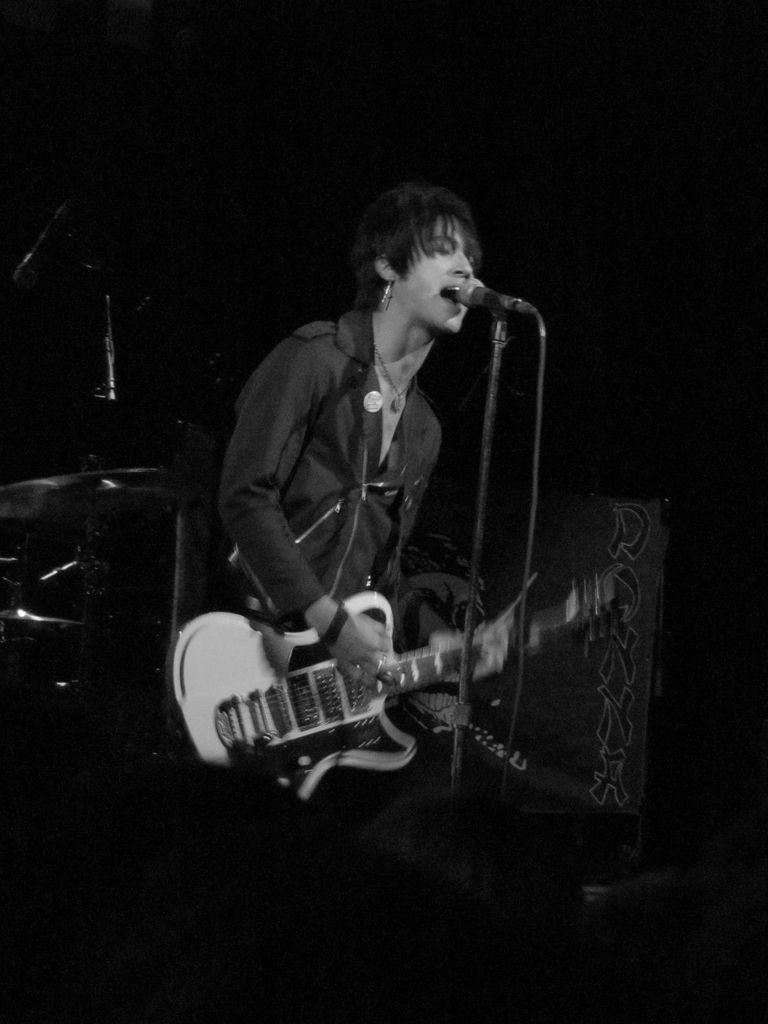Describe this image in one or two sentences. In the middle of the image a woman is playing guitar and singing. In front of her there is a microphone. Behind her there is a drum. 